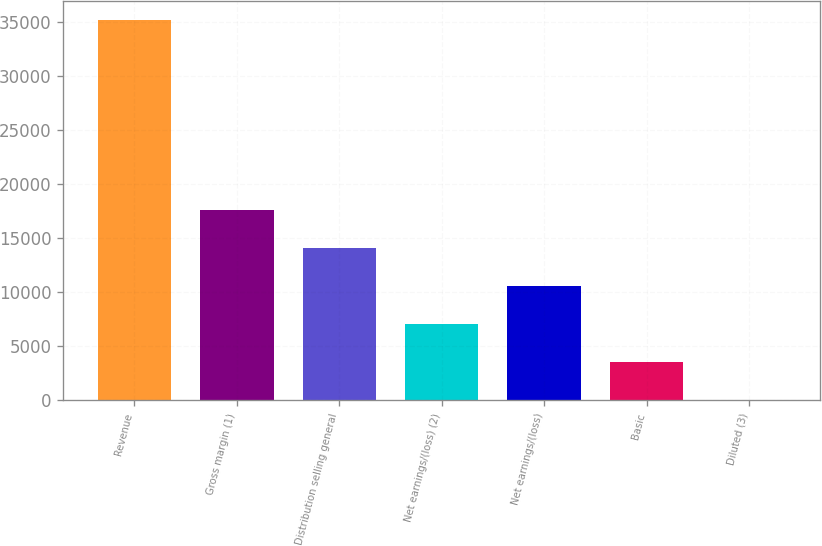<chart> <loc_0><loc_0><loc_500><loc_500><bar_chart><fcel>Revenue<fcel>Gross margin (1)<fcel>Distribution selling general<fcel>Net earnings/(loss) (2)<fcel>Net earnings/(loss)<fcel>Basic<fcel>Diluted (3)<nl><fcel>35186<fcel>17594.7<fcel>14076.4<fcel>7039.87<fcel>10558.1<fcel>3521.6<fcel>3.33<nl></chart> 